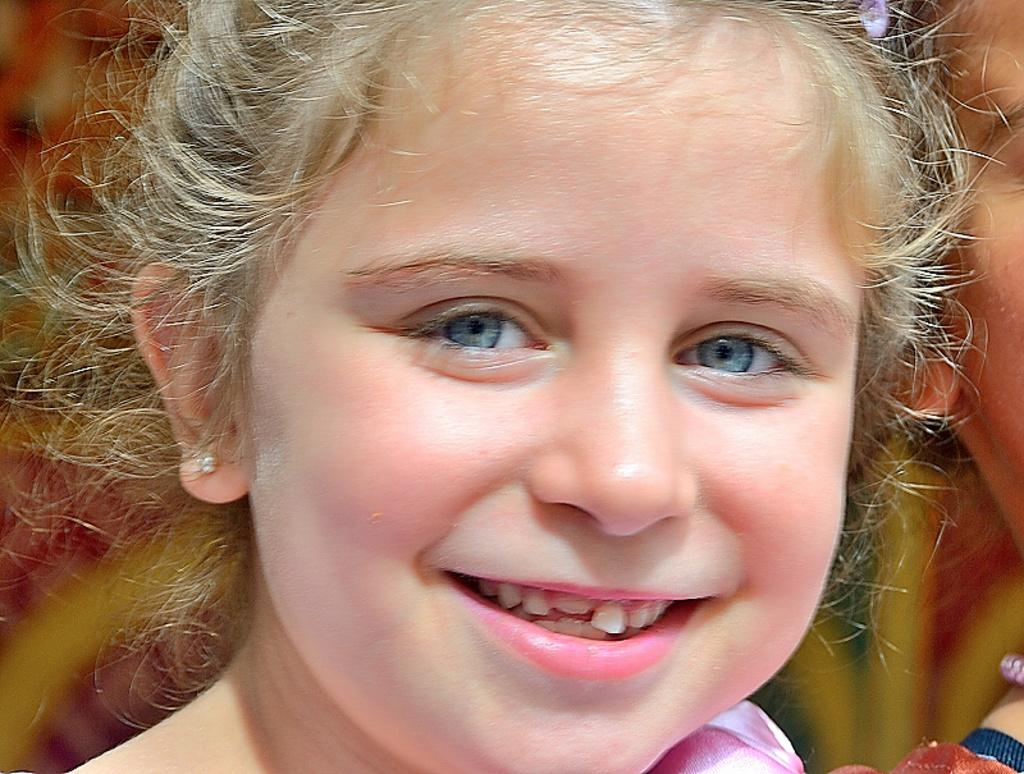Who is present in the image? There is a girl in the image. What expression does the girl have? The girl is smiling. What type of army uniform is the beggar wearing in the image? There is no beggar or army uniform present in the image. 